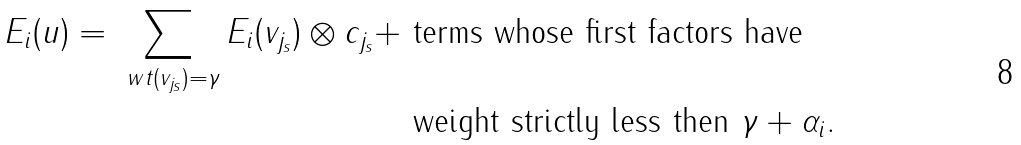Convert formula to latex. <formula><loc_0><loc_0><loc_500><loc_500>E _ { i } ( u ) = \sum _ { \ w t ( v _ { j _ { s } } ) = \gamma } E _ { i } ( v _ { j _ { s } } ) \otimes c _ { j _ { s } } + & \text { terms whose first factors have } \\ & \text { weight strictly less then } \gamma + \alpha _ { i } .</formula> 